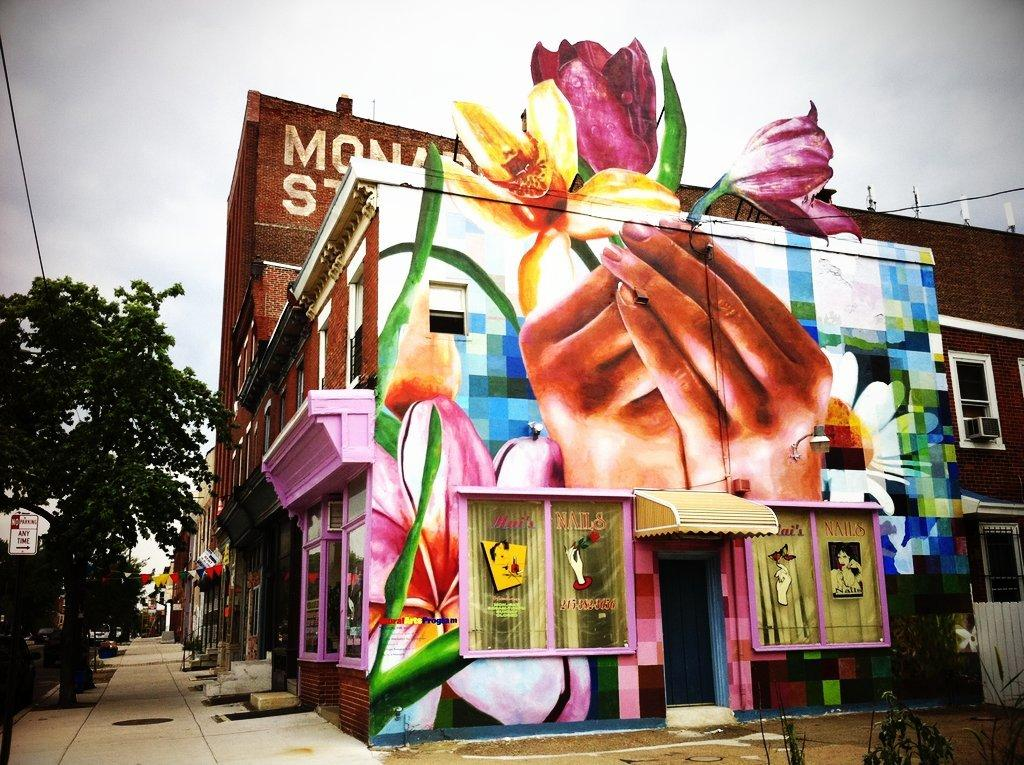What type of structures can be seen in the image? There are buildings in the image. What is on the wall of one of the buildings? There is a painting on a wall in the image. What can be seen on the left side of the image? There are trees and wires on the left side of the image. What is visible in the background of the image? The sky is visible in the background of the image. Where are the tomatoes growing in the image? There are no tomatoes present in the image. What type of clothing is the monkey wearing in the image? There is no monkey present in the image. 